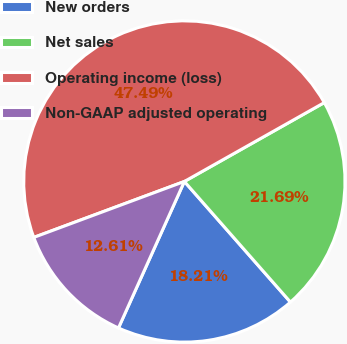Convert chart. <chart><loc_0><loc_0><loc_500><loc_500><pie_chart><fcel>New orders<fcel>Net sales<fcel>Operating income (loss)<fcel>Non-GAAP adjusted operating<nl><fcel>18.21%<fcel>21.69%<fcel>47.49%<fcel>12.61%<nl></chart> 